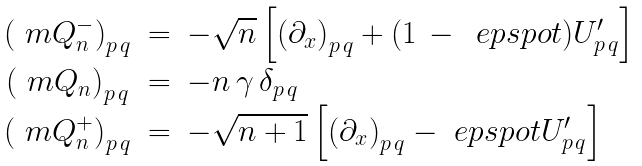<formula> <loc_0><loc_0><loc_500><loc_500>\begin{array} { c c l } \left ( \ m Q _ { n } ^ { - } \right ) _ { p \, q } & = & - \sqrt { n } \left [ \left ( \partial _ { x } \right ) _ { p \, q } + ( 1 \, - \, \ e p s p o t ) U _ { p \, q } ^ { \prime } \right ] \\ \left ( \ m Q _ { n } \right ) _ { p \, q } & = & - n \, \gamma \, \delta _ { p \, q } \\ \left ( \ m Q _ { n } ^ { + } \right ) _ { p \, q } & = & - \sqrt { n + 1 } \left [ \left ( \partial _ { x } \right ) _ { p \, q } - \ e p s p o t U _ { p \, q } ^ { \prime } \right ] \end{array}</formula> 